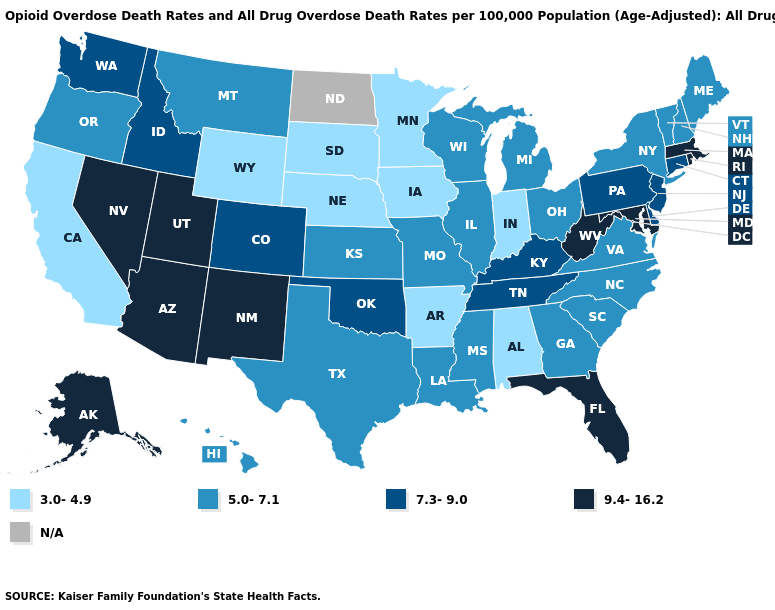Name the states that have a value in the range N/A?
Keep it brief. North Dakota. Name the states that have a value in the range 5.0-7.1?
Write a very short answer. Georgia, Hawaii, Illinois, Kansas, Louisiana, Maine, Michigan, Mississippi, Missouri, Montana, New Hampshire, New York, North Carolina, Ohio, Oregon, South Carolina, Texas, Vermont, Virginia, Wisconsin. Does South Carolina have the lowest value in the South?
Write a very short answer. No. Name the states that have a value in the range 9.4-16.2?
Keep it brief. Alaska, Arizona, Florida, Maryland, Massachusetts, Nevada, New Mexico, Rhode Island, Utah, West Virginia. Does New Hampshire have the highest value in the USA?
Concise answer only. No. Among the states that border Michigan , which have the highest value?
Answer briefly. Ohio, Wisconsin. Name the states that have a value in the range 7.3-9.0?
Quick response, please. Colorado, Connecticut, Delaware, Idaho, Kentucky, New Jersey, Oklahoma, Pennsylvania, Tennessee, Washington. Does Iowa have the lowest value in the USA?
Quick response, please. Yes. Among the states that border Kansas , does Oklahoma have the highest value?
Be succinct. Yes. What is the lowest value in the MidWest?
Be succinct. 3.0-4.9. Does Georgia have the highest value in the South?
Give a very brief answer. No. Is the legend a continuous bar?
Answer briefly. No. What is the value of North Dakota?
Keep it brief. N/A. What is the lowest value in the MidWest?
Be succinct. 3.0-4.9. What is the lowest value in the USA?
Be succinct. 3.0-4.9. 